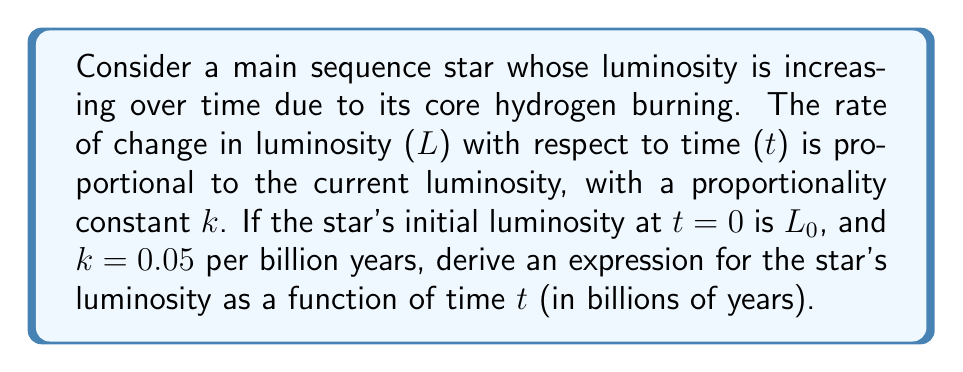What is the answer to this math problem? To solve this problem, we'll use the following steps:

1) First, we need to translate the given information into a differential equation. The rate of change of luminosity with respect to time is proportional to the current luminosity:

   $$\frac{dL}{dt} = kL$$

   Where k = 0.05 per billion years.

2) This is a separable first-order differential equation. We can solve it by separating variables:

   $$\frac{dL}{L} = k dt$$

3) Integrate both sides:

   $$\int \frac{dL}{L} = \int k dt$$

4) This gives us:

   $$\ln|L| = kt + C$$

   Where C is the constant of integration.

5) Exponentiate both sides:

   $$L = e^{kt + C} = e^C \cdot e^{kt}$$

6) We can simplify this by letting $e^C = A$, where A is a new constant:

   $$L = A \cdot e^{kt}$$

7) To find A, we use the initial condition. At t=0, L=L₀:

   $$L_0 = A \cdot e^{k \cdot 0} = A$$

8) Therefore, our final expression is:

   $$L(t) = L_0 \cdot e^{kt}$$

9) Substituting the given value of k:

   $$L(t) = L_0 \cdot e^{0.05t}$$

Where t is in billions of years.
Answer: $$L(t) = L_0 \cdot e^{0.05t}$$
Where L(t) is the luminosity at time t, L₀ is the initial luminosity, and t is in billions of years. 